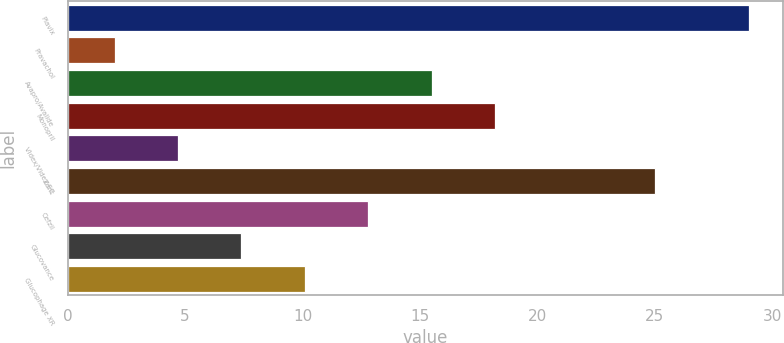Convert chart to OTSL. <chart><loc_0><loc_0><loc_500><loc_500><bar_chart><fcel>Plavix<fcel>Pravachol<fcel>Avapro/Avalide<fcel>Monopril<fcel>Videx/Videx EC<fcel>Zerit<fcel>Cefzil<fcel>Glucovance<fcel>Glucophage XR<nl><fcel>29<fcel>2<fcel>15.5<fcel>18.2<fcel>4.7<fcel>25<fcel>12.8<fcel>7.4<fcel>10.1<nl></chart> 